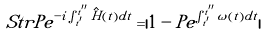<formula> <loc_0><loc_0><loc_500><loc_500>S t r P e ^ { - i \int _ { t ^ { \prime } } ^ { t ^ { \prime \prime } } \hat { H } ( t ) d t } = | 1 - P e ^ { \int _ { t ^ { \prime } } ^ { t ^ { \prime \prime } } \omega ( t ) d t } |</formula> 